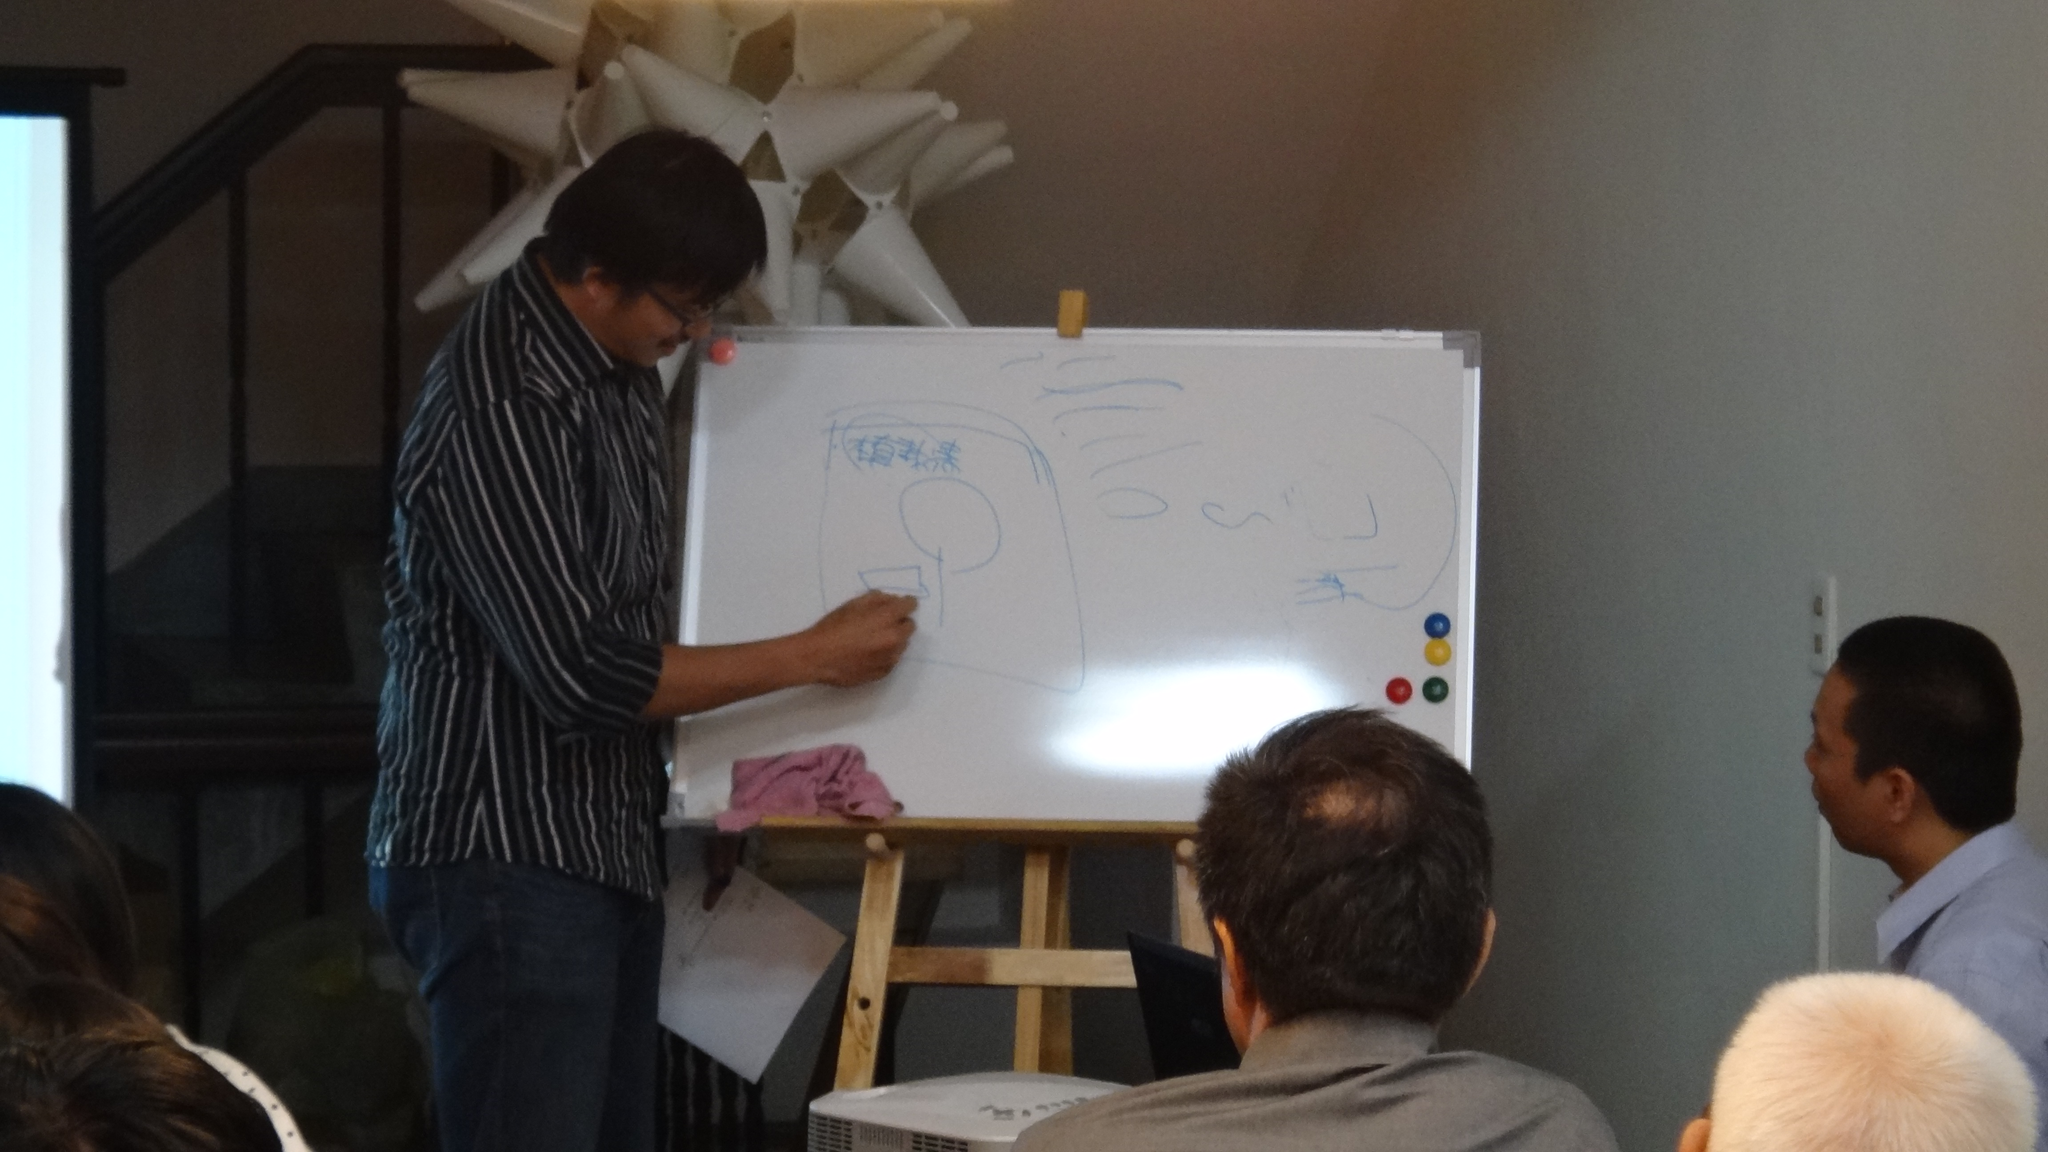Please provide a concise description of this image. This image is taken indoors. In the background there is a wall. There is a raining. There is an architecture. At the bottom of the image there are a few people. In the middle of the image a man is standing and he is writing on the board with a marker pen. There is a board with a text on it. There is a cloth and there is a device. 